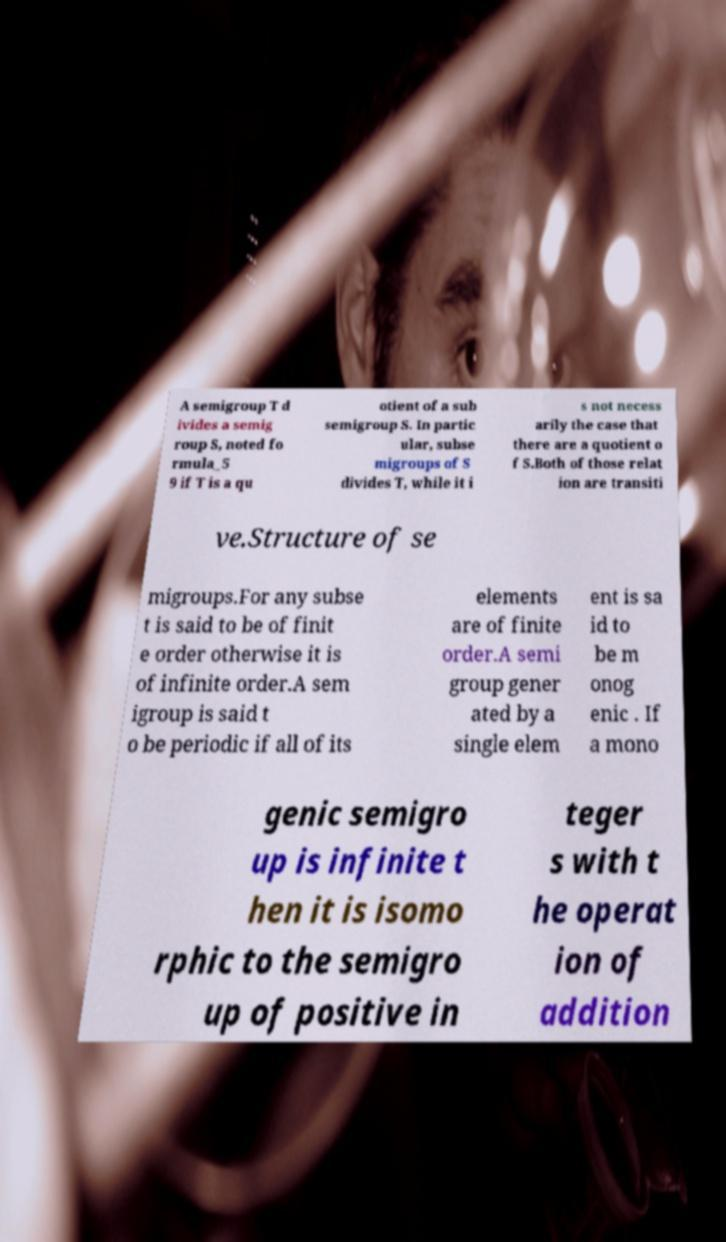Please identify and transcribe the text found in this image. A semigroup T d ivides a semig roup S, noted fo rmula_5 9 if T is a qu otient of a sub semigroup S. In partic ular, subse migroups of S divides T, while it i s not necess arily the case that there are a quotient o f S.Both of those relat ion are transiti ve.Structure of se migroups.For any subse t is said to be of finit e order otherwise it is of infinite order.A sem igroup is said t o be periodic if all of its elements are of finite order.A semi group gener ated by a single elem ent is sa id to be m onog enic . If a mono genic semigro up is infinite t hen it is isomo rphic to the semigro up of positive in teger s with t he operat ion of addition 